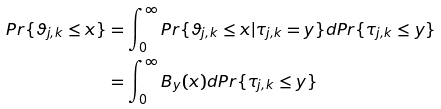<formula> <loc_0><loc_0><loc_500><loc_500>P r \{ \vartheta _ { j , k } \leq x \} & = \int _ { 0 } ^ { \infty } P r \{ \vartheta _ { j , k } \leq x | \tau _ { j , k } = y \} d P r \{ \tau _ { j , k } \leq y \} \\ & = \int _ { 0 } ^ { \infty } B _ { y } ( x ) d P r \{ \tau _ { j , k } \leq y \}</formula> 